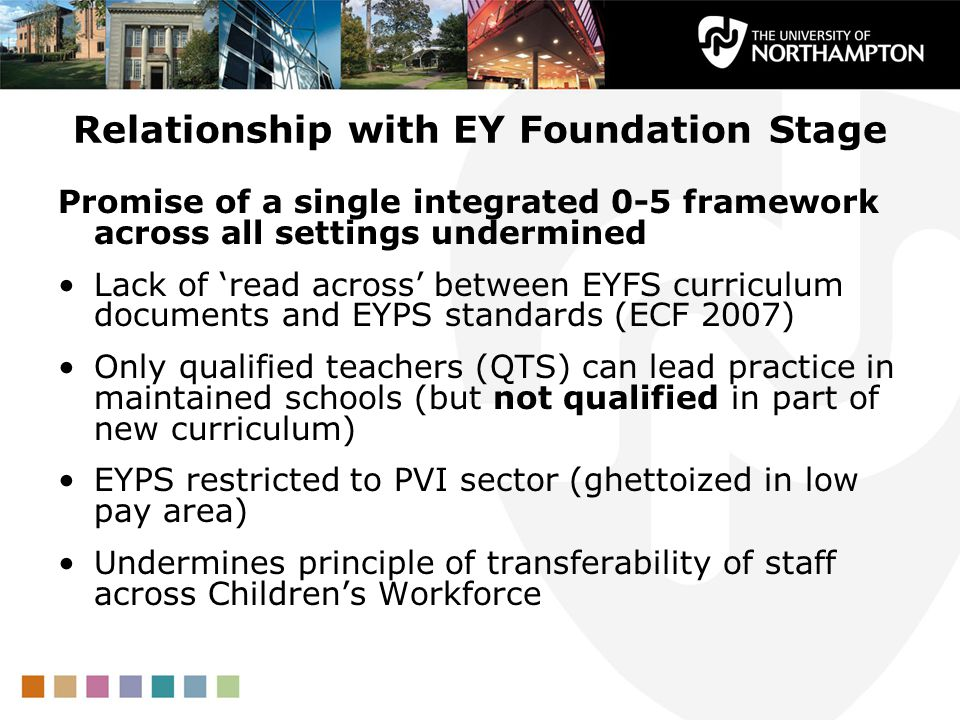If the framework were a living entity, how would it deal with the issues it faces? If the EYFS framework were a living entity, it might tackle its challenges through adaptive and regenerative processes. Imagine it as a wise, nurturing figure, constantly aware of the needs of both educators and children. To address qualifications, it could offer ongoing training workshops and mentorship programs, empowering teachers with the knowledge and skills required for the new curriculum. For issues of staff mobility and pay disparities, this entity would foster an inclusive, cooperative network, seamlessly integrating public and private institutions and ensuring fair compensation to retain skilled professionals. It would be like a gardener, cultivating a vibrant and sustainable ecosystem where teachers and children thrive together, consistently nurturing growth and learning. 